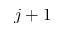Convert formula to latex. <formula><loc_0><loc_0><loc_500><loc_500>j + 1</formula> 